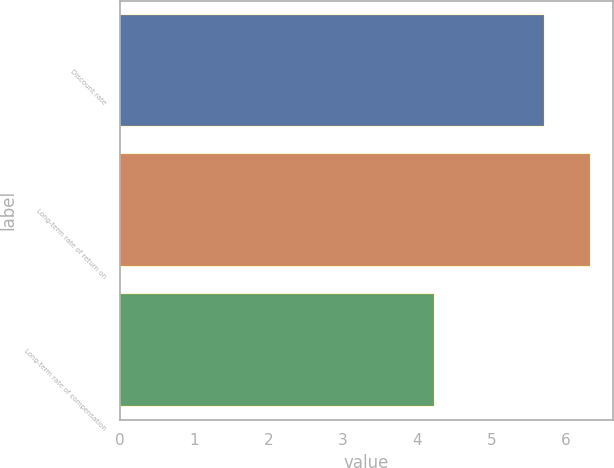Convert chart. <chart><loc_0><loc_0><loc_500><loc_500><bar_chart><fcel>Discount rate<fcel>Long-term rate of return on<fcel>Long-term rate of compensation<nl><fcel>5.7<fcel>6.32<fcel>4.22<nl></chart> 